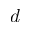Convert formula to latex. <formula><loc_0><loc_0><loc_500><loc_500>d</formula> 